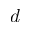Convert formula to latex. <formula><loc_0><loc_0><loc_500><loc_500>d</formula> 